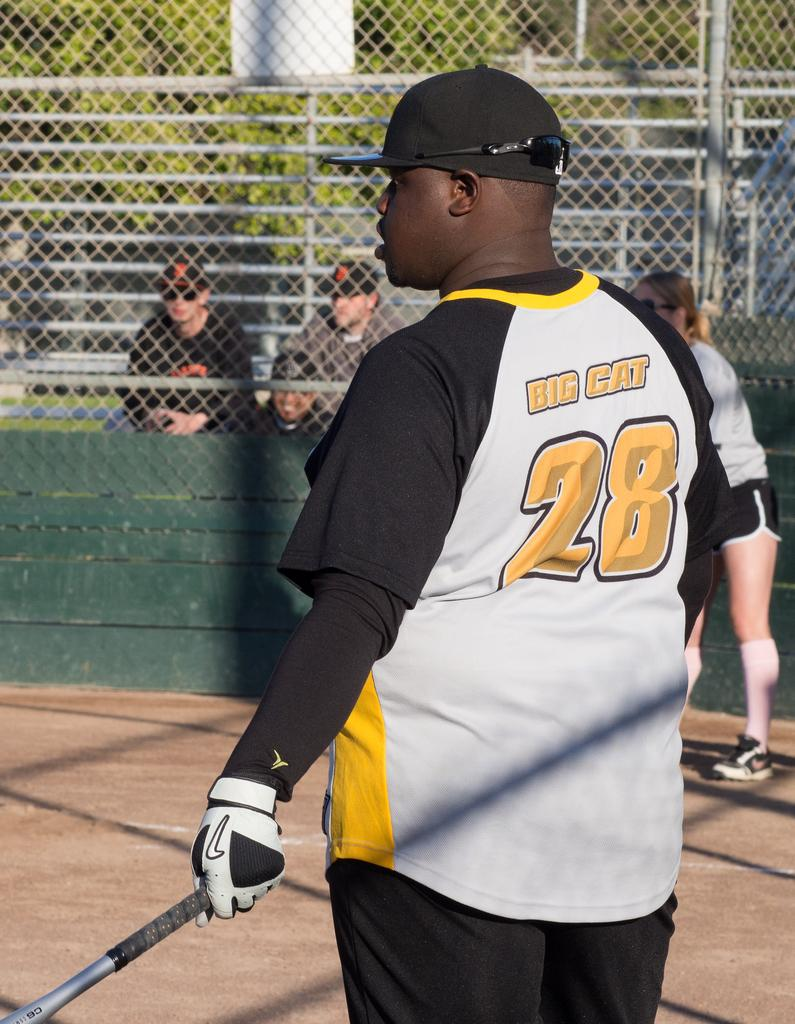<image>
Present a compact description of the photo's key features. Baseball player bat in hand wearing a black and yellow jersey with the number 28 and Big Cat. 